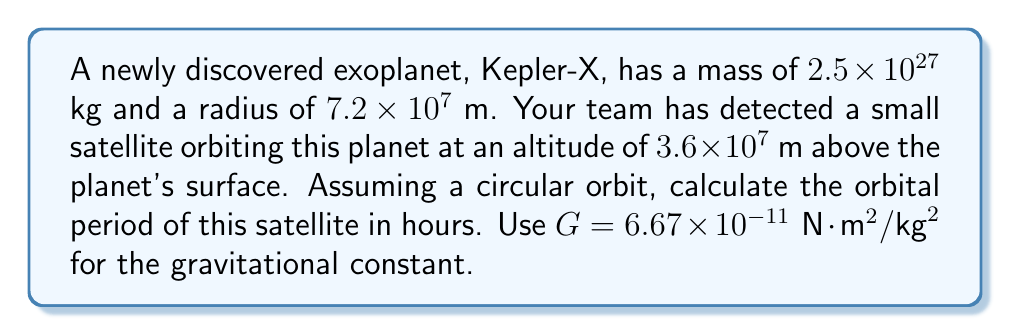Give your solution to this math problem. To solve this problem, we'll use Kepler's Third Law of planetary motion, which relates the orbital period to the orbit's radius and the mass of the central body. The steps are as follows:

1) First, calculate the total radius of the orbit:
   $$r = \text{planet radius} + \text{altitude} = 7.2 \times 10^7 \text{ m} + 3.6 \times 10^7 \text{ m} = 1.08 \times 10^8 \text{ m}$$

2) Kepler's Third Law in its modern form is:
   $$T = 2\pi\sqrt{\frac{r^3}{GM}}$$
   where $T$ is the orbital period, $r$ is the orbit radius, $G$ is the gravitational constant, and $M$ is the mass of the central body.

3) Substitute the known values:
   $$T = 2\pi\sqrt{\frac{(1.08 \times 10^8 \text{ m})^3}{(6.67 \times 10^{-11} \text{ N}\cdot\text{m}^2/\text{kg}^2)(2.5 \times 10^{27} \text{ kg})}}$$

4) Simplify inside the square root:
   $$T = 2\pi\sqrt{\frac{1.2597 \times 10^{24}}{1.6675 \times 10^{17}}} = 2\pi\sqrt{7.5544 \times 10^6}$$

5) Calculate:
   $$T = 2\pi(2749.44) = 17,275.86 \text{ seconds}$$

6) Convert to hours:
   $$T = \frac{17,275.86 \text{ seconds}}{3600 \text{ seconds/hour}} = 4.80 \text{ hours}$$

Thus, the orbital period of the satellite is approximately 4.80 hours.
Answer: 4.80 hours 